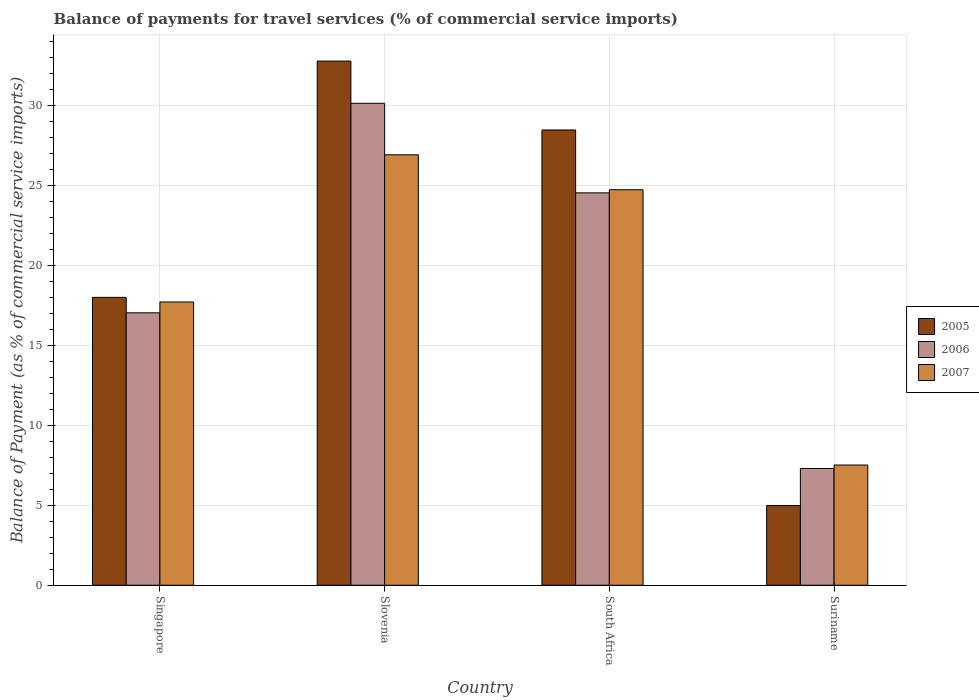Are the number of bars per tick equal to the number of legend labels?
Your answer should be very brief. Yes. Are the number of bars on each tick of the X-axis equal?
Offer a terse response. Yes. How many bars are there on the 3rd tick from the right?
Provide a short and direct response. 3. What is the label of the 1st group of bars from the left?
Give a very brief answer. Singapore. What is the balance of payments for travel services in 2006 in Singapore?
Offer a very short reply. 17.02. Across all countries, what is the maximum balance of payments for travel services in 2007?
Offer a terse response. 26.9. Across all countries, what is the minimum balance of payments for travel services in 2005?
Provide a succinct answer. 4.98. In which country was the balance of payments for travel services in 2005 maximum?
Your response must be concise. Slovenia. In which country was the balance of payments for travel services in 2006 minimum?
Your answer should be compact. Suriname. What is the total balance of payments for travel services in 2007 in the graph?
Make the answer very short. 76.82. What is the difference between the balance of payments for travel services in 2005 in Singapore and that in Suriname?
Your answer should be compact. 13.01. What is the difference between the balance of payments for travel services in 2005 in Suriname and the balance of payments for travel services in 2007 in South Africa?
Provide a short and direct response. -19.73. What is the average balance of payments for travel services in 2006 per country?
Offer a very short reply. 19.74. What is the difference between the balance of payments for travel services of/in 2007 and balance of payments for travel services of/in 2005 in Slovenia?
Ensure brevity in your answer.  -5.86. In how many countries, is the balance of payments for travel services in 2005 greater than 19 %?
Provide a short and direct response. 2. What is the ratio of the balance of payments for travel services in 2005 in Slovenia to that in Suriname?
Ensure brevity in your answer.  6.57. Is the balance of payments for travel services in 2005 in South Africa less than that in Suriname?
Ensure brevity in your answer.  No. What is the difference between the highest and the second highest balance of payments for travel services in 2006?
Ensure brevity in your answer.  7.5. What is the difference between the highest and the lowest balance of payments for travel services in 2007?
Offer a very short reply. 19.38. In how many countries, is the balance of payments for travel services in 2005 greater than the average balance of payments for travel services in 2005 taken over all countries?
Provide a short and direct response. 2. What does the 1st bar from the left in Singapore represents?
Your response must be concise. 2005. Is it the case that in every country, the sum of the balance of payments for travel services in 2005 and balance of payments for travel services in 2006 is greater than the balance of payments for travel services in 2007?
Give a very brief answer. Yes. How many bars are there?
Offer a terse response. 12. Are all the bars in the graph horizontal?
Your answer should be very brief. No. What is the difference between two consecutive major ticks on the Y-axis?
Make the answer very short. 5. Does the graph contain grids?
Offer a terse response. Yes. How are the legend labels stacked?
Offer a very short reply. Vertical. What is the title of the graph?
Provide a succinct answer. Balance of payments for travel services (% of commercial service imports). Does "1978" appear as one of the legend labels in the graph?
Your response must be concise. No. What is the label or title of the X-axis?
Offer a terse response. Country. What is the label or title of the Y-axis?
Give a very brief answer. Balance of Payment (as % of commercial service imports). What is the Balance of Payment (as % of commercial service imports) in 2005 in Singapore?
Your answer should be compact. 17.99. What is the Balance of Payment (as % of commercial service imports) of 2006 in Singapore?
Provide a succinct answer. 17.02. What is the Balance of Payment (as % of commercial service imports) of 2007 in Singapore?
Give a very brief answer. 17.7. What is the Balance of Payment (as % of commercial service imports) in 2005 in Slovenia?
Provide a succinct answer. 32.75. What is the Balance of Payment (as % of commercial service imports) in 2006 in Slovenia?
Offer a very short reply. 30.11. What is the Balance of Payment (as % of commercial service imports) in 2007 in Slovenia?
Your response must be concise. 26.9. What is the Balance of Payment (as % of commercial service imports) in 2005 in South Africa?
Offer a terse response. 28.45. What is the Balance of Payment (as % of commercial service imports) of 2006 in South Africa?
Offer a very short reply. 24.52. What is the Balance of Payment (as % of commercial service imports) in 2007 in South Africa?
Offer a terse response. 24.71. What is the Balance of Payment (as % of commercial service imports) in 2005 in Suriname?
Make the answer very short. 4.98. What is the Balance of Payment (as % of commercial service imports) of 2006 in Suriname?
Provide a succinct answer. 7.29. What is the Balance of Payment (as % of commercial service imports) in 2007 in Suriname?
Make the answer very short. 7.51. Across all countries, what is the maximum Balance of Payment (as % of commercial service imports) of 2005?
Ensure brevity in your answer.  32.75. Across all countries, what is the maximum Balance of Payment (as % of commercial service imports) in 2006?
Offer a terse response. 30.11. Across all countries, what is the maximum Balance of Payment (as % of commercial service imports) of 2007?
Offer a very short reply. 26.9. Across all countries, what is the minimum Balance of Payment (as % of commercial service imports) in 2005?
Offer a very short reply. 4.98. Across all countries, what is the minimum Balance of Payment (as % of commercial service imports) of 2006?
Make the answer very short. 7.29. Across all countries, what is the minimum Balance of Payment (as % of commercial service imports) of 2007?
Make the answer very short. 7.51. What is the total Balance of Payment (as % of commercial service imports) in 2005 in the graph?
Ensure brevity in your answer.  84.17. What is the total Balance of Payment (as % of commercial service imports) in 2006 in the graph?
Provide a succinct answer. 78.95. What is the total Balance of Payment (as % of commercial service imports) in 2007 in the graph?
Your response must be concise. 76.82. What is the difference between the Balance of Payment (as % of commercial service imports) in 2005 in Singapore and that in Slovenia?
Ensure brevity in your answer.  -14.76. What is the difference between the Balance of Payment (as % of commercial service imports) in 2006 in Singapore and that in Slovenia?
Keep it short and to the point. -13.09. What is the difference between the Balance of Payment (as % of commercial service imports) of 2007 in Singapore and that in Slovenia?
Give a very brief answer. -9.2. What is the difference between the Balance of Payment (as % of commercial service imports) of 2005 in Singapore and that in South Africa?
Your response must be concise. -10.46. What is the difference between the Balance of Payment (as % of commercial service imports) of 2006 in Singapore and that in South Africa?
Make the answer very short. -7.5. What is the difference between the Balance of Payment (as % of commercial service imports) of 2007 in Singapore and that in South Africa?
Your answer should be compact. -7.01. What is the difference between the Balance of Payment (as % of commercial service imports) of 2005 in Singapore and that in Suriname?
Provide a short and direct response. 13.01. What is the difference between the Balance of Payment (as % of commercial service imports) of 2006 in Singapore and that in Suriname?
Provide a short and direct response. 9.73. What is the difference between the Balance of Payment (as % of commercial service imports) in 2007 in Singapore and that in Suriname?
Ensure brevity in your answer.  10.19. What is the difference between the Balance of Payment (as % of commercial service imports) in 2005 in Slovenia and that in South Africa?
Provide a succinct answer. 4.3. What is the difference between the Balance of Payment (as % of commercial service imports) of 2006 in Slovenia and that in South Africa?
Your response must be concise. 5.6. What is the difference between the Balance of Payment (as % of commercial service imports) of 2007 in Slovenia and that in South Africa?
Keep it short and to the point. 2.18. What is the difference between the Balance of Payment (as % of commercial service imports) in 2005 in Slovenia and that in Suriname?
Provide a succinct answer. 27.77. What is the difference between the Balance of Payment (as % of commercial service imports) in 2006 in Slovenia and that in Suriname?
Your answer should be compact. 22.82. What is the difference between the Balance of Payment (as % of commercial service imports) in 2007 in Slovenia and that in Suriname?
Offer a terse response. 19.38. What is the difference between the Balance of Payment (as % of commercial service imports) of 2005 in South Africa and that in Suriname?
Your answer should be compact. 23.46. What is the difference between the Balance of Payment (as % of commercial service imports) in 2006 in South Africa and that in Suriname?
Make the answer very short. 17.22. What is the difference between the Balance of Payment (as % of commercial service imports) in 2007 in South Africa and that in Suriname?
Offer a terse response. 17.2. What is the difference between the Balance of Payment (as % of commercial service imports) in 2005 in Singapore and the Balance of Payment (as % of commercial service imports) in 2006 in Slovenia?
Your response must be concise. -12.13. What is the difference between the Balance of Payment (as % of commercial service imports) in 2005 in Singapore and the Balance of Payment (as % of commercial service imports) in 2007 in Slovenia?
Give a very brief answer. -8.91. What is the difference between the Balance of Payment (as % of commercial service imports) in 2006 in Singapore and the Balance of Payment (as % of commercial service imports) in 2007 in Slovenia?
Keep it short and to the point. -9.87. What is the difference between the Balance of Payment (as % of commercial service imports) of 2005 in Singapore and the Balance of Payment (as % of commercial service imports) of 2006 in South Africa?
Offer a very short reply. -6.53. What is the difference between the Balance of Payment (as % of commercial service imports) of 2005 in Singapore and the Balance of Payment (as % of commercial service imports) of 2007 in South Africa?
Offer a very short reply. -6.73. What is the difference between the Balance of Payment (as % of commercial service imports) in 2006 in Singapore and the Balance of Payment (as % of commercial service imports) in 2007 in South Africa?
Offer a very short reply. -7.69. What is the difference between the Balance of Payment (as % of commercial service imports) of 2005 in Singapore and the Balance of Payment (as % of commercial service imports) of 2006 in Suriname?
Your answer should be compact. 10.69. What is the difference between the Balance of Payment (as % of commercial service imports) in 2005 in Singapore and the Balance of Payment (as % of commercial service imports) in 2007 in Suriname?
Offer a terse response. 10.48. What is the difference between the Balance of Payment (as % of commercial service imports) of 2006 in Singapore and the Balance of Payment (as % of commercial service imports) of 2007 in Suriname?
Offer a terse response. 9.51. What is the difference between the Balance of Payment (as % of commercial service imports) in 2005 in Slovenia and the Balance of Payment (as % of commercial service imports) in 2006 in South Africa?
Ensure brevity in your answer.  8.23. What is the difference between the Balance of Payment (as % of commercial service imports) of 2005 in Slovenia and the Balance of Payment (as % of commercial service imports) of 2007 in South Africa?
Offer a terse response. 8.04. What is the difference between the Balance of Payment (as % of commercial service imports) of 2006 in Slovenia and the Balance of Payment (as % of commercial service imports) of 2007 in South Africa?
Ensure brevity in your answer.  5.4. What is the difference between the Balance of Payment (as % of commercial service imports) of 2005 in Slovenia and the Balance of Payment (as % of commercial service imports) of 2006 in Suriname?
Your response must be concise. 25.46. What is the difference between the Balance of Payment (as % of commercial service imports) in 2005 in Slovenia and the Balance of Payment (as % of commercial service imports) in 2007 in Suriname?
Give a very brief answer. 25.24. What is the difference between the Balance of Payment (as % of commercial service imports) of 2006 in Slovenia and the Balance of Payment (as % of commercial service imports) of 2007 in Suriname?
Your response must be concise. 22.6. What is the difference between the Balance of Payment (as % of commercial service imports) in 2005 in South Africa and the Balance of Payment (as % of commercial service imports) in 2006 in Suriname?
Provide a short and direct response. 21.15. What is the difference between the Balance of Payment (as % of commercial service imports) of 2005 in South Africa and the Balance of Payment (as % of commercial service imports) of 2007 in Suriname?
Offer a terse response. 20.94. What is the difference between the Balance of Payment (as % of commercial service imports) in 2006 in South Africa and the Balance of Payment (as % of commercial service imports) in 2007 in Suriname?
Offer a terse response. 17.01. What is the average Balance of Payment (as % of commercial service imports) of 2005 per country?
Make the answer very short. 21.04. What is the average Balance of Payment (as % of commercial service imports) of 2006 per country?
Ensure brevity in your answer.  19.74. What is the average Balance of Payment (as % of commercial service imports) of 2007 per country?
Ensure brevity in your answer.  19.2. What is the difference between the Balance of Payment (as % of commercial service imports) of 2005 and Balance of Payment (as % of commercial service imports) of 2006 in Singapore?
Your answer should be compact. 0.97. What is the difference between the Balance of Payment (as % of commercial service imports) of 2005 and Balance of Payment (as % of commercial service imports) of 2007 in Singapore?
Your response must be concise. 0.29. What is the difference between the Balance of Payment (as % of commercial service imports) in 2006 and Balance of Payment (as % of commercial service imports) in 2007 in Singapore?
Provide a succinct answer. -0.68. What is the difference between the Balance of Payment (as % of commercial service imports) in 2005 and Balance of Payment (as % of commercial service imports) in 2006 in Slovenia?
Give a very brief answer. 2.64. What is the difference between the Balance of Payment (as % of commercial service imports) in 2005 and Balance of Payment (as % of commercial service imports) in 2007 in Slovenia?
Your answer should be compact. 5.86. What is the difference between the Balance of Payment (as % of commercial service imports) of 2006 and Balance of Payment (as % of commercial service imports) of 2007 in Slovenia?
Your answer should be compact. 3.22. What is the difference between the Balance of Payment (as % of commercial service imports) in 2005 and Balance of Payment (as % of commercial service imports) in 2006 in South Africa?
Offer a very short reply. 3.93. What is the difference between the Balance of Payment (as % of commercial service imports) of 2005 and Balance of Payment (as % of commercial service imports) of 2007 in South Africa?
Provide a succinct answer. 3.73. What is the difference between the Balance of Payment (as % of commercial service imports) in 2006 and Balance of Payment (as % of commercial service imports) in 2007 in South Africa?
Make the answer very short. -0.2. What is the difference between the Balance of Payment (as % of commercial service imports) of 2005 and Balance of Payment (as % of commercial service imports) of 2006 in Suriname?
Provide a short and direct response. -2.31. What is the difference between the Balance of Payment (as % of commercial service imports) in 2005 and Balance of Payment (as % of commercial service imports) in 2007 in Suriname?
Your answer should be very brief. -2.53. What is the difference between the Balance of Payment (as % of commercial service imports) of 2006 and Balance of Payment (as % of commercial service imports) of 2007 in Suriname?
Provide a succinct answer. -0.22. What is the ratio of the Balance of Payment (as % of commercial service imports) in 2005 in Singapore to that in Slovenia?
Offer a terse response. 0.55. What is the ratio of the Balance of Payment (as % of commercial service imports) of 2006 in Singapore to that in Slovenia?
Ensure brevity in your answer.  0.57. What is the ratio of the Balance of Payment (as % of commercial service imports) of 2007 in Singapore to that in Slovenia?
Your answer should be very brief. 0.66. What is the ratio of the Balance of Payment (as % of commercial service imports) of 2005 in Singapore to that in South Africa?
Ensure brevity in your answer.  0.63. What is the ratio of the Balance of Payment (as % of commercial service imports) of 2006 in Singapore to that in South Africa?
Provide a succinct answer. 0.69. What is the ratio of the Balance of Payment (as % of commercial service imports) of 2007 in Singapore to that in South Africa?
Provide a succinct answer. 0.72. What is the ratio of the Balance of Payment (as % of commercial service imports) of 2005 in Singapore to that in Suriname?
Your answer should be compact. 3.61. What is the ratio of the Balance of Payment (as % of commercial service imports) of 2006 in Singapore to that in Suriname?
Your answer should be very brief. 2.33. What is the ratio of the Balance of Payment (as % of commercial service imports) of 2007 in Singapore to that in Suriname?
Your response must be concise. 2.36. What is the ratio of the Balance of Payment (as % of commercial service imports) in 2005 in Slovenia to that in South Africa?
Your response must be concise. 1.15. What is the ratio of the Balance of Payment (as % of commercial service imports) in 2006 in Slovenia to that in South Africa?
Offer a terse response. 1.23. What is the ratio of the Balance of Payment (as % of commercial service imports) of 2007 in Slovenia to that in South Africa?
Offer a terse response. 1.09. What is the ratio of the Balance of Payment (as % of commercial service imports) of 2005 in Slovenia to that in Suriname?
Offer a very short reply. 6.57. What is the ratio of the Balance of Payment (as % of commercial service imports) in 2006 in Slovenia to that in Suriname?
Make the answer very short. 4.13. What is the ratio of the Balance of Payment (as % of commercial service imports) of 2007 in Slovenia to that in Suriname?
Your answer should be compact. 3.58. What is the ratio of the Balance of Payment (as % of commercial service imports) in 2005 in South Africa to that in Suriname?
Provide a succinct answer. 5.71. What is the ratio of the Balance of Payment (as % of commercial service imports) in 2006 in South Africa to that in Suriname?
Provide a short and direct response. 3.36. What is the ratio of the Balance of Payment (as % of commercial service imports) in 2007 in South Africa to that in Suriname?
Offer a terse response. 3.29. What is the difference between the highest and the second highest Balance of Payment (as % of commercial service imports) in 2005?
Ensure brevity in your answer.  4.3. What is the difference between the highest and the second highest Balance of Payment (as % of commercial service imports) of 2006?
Your answer should be compact. 5.6. What is the difference between the highest and the second highest Balance of Payment (as % of commercial service imports) of 2007?
Make the answer very short. 2.18. What is the difference between the highest and the lowest Balance of Payment (as % of commercial service imports) in 2005?
Your response must be concise. 27.77. What is the difference between the highest and the lowest Balance of Payment (as % of commercial service imports) in 2006?
Your answer should be very brief. 22.82. What is the difference between the highest and the lowest Balance of Payment (as % of commercial service imports) in 2007?
Your answer should be very brief. 19.38. 